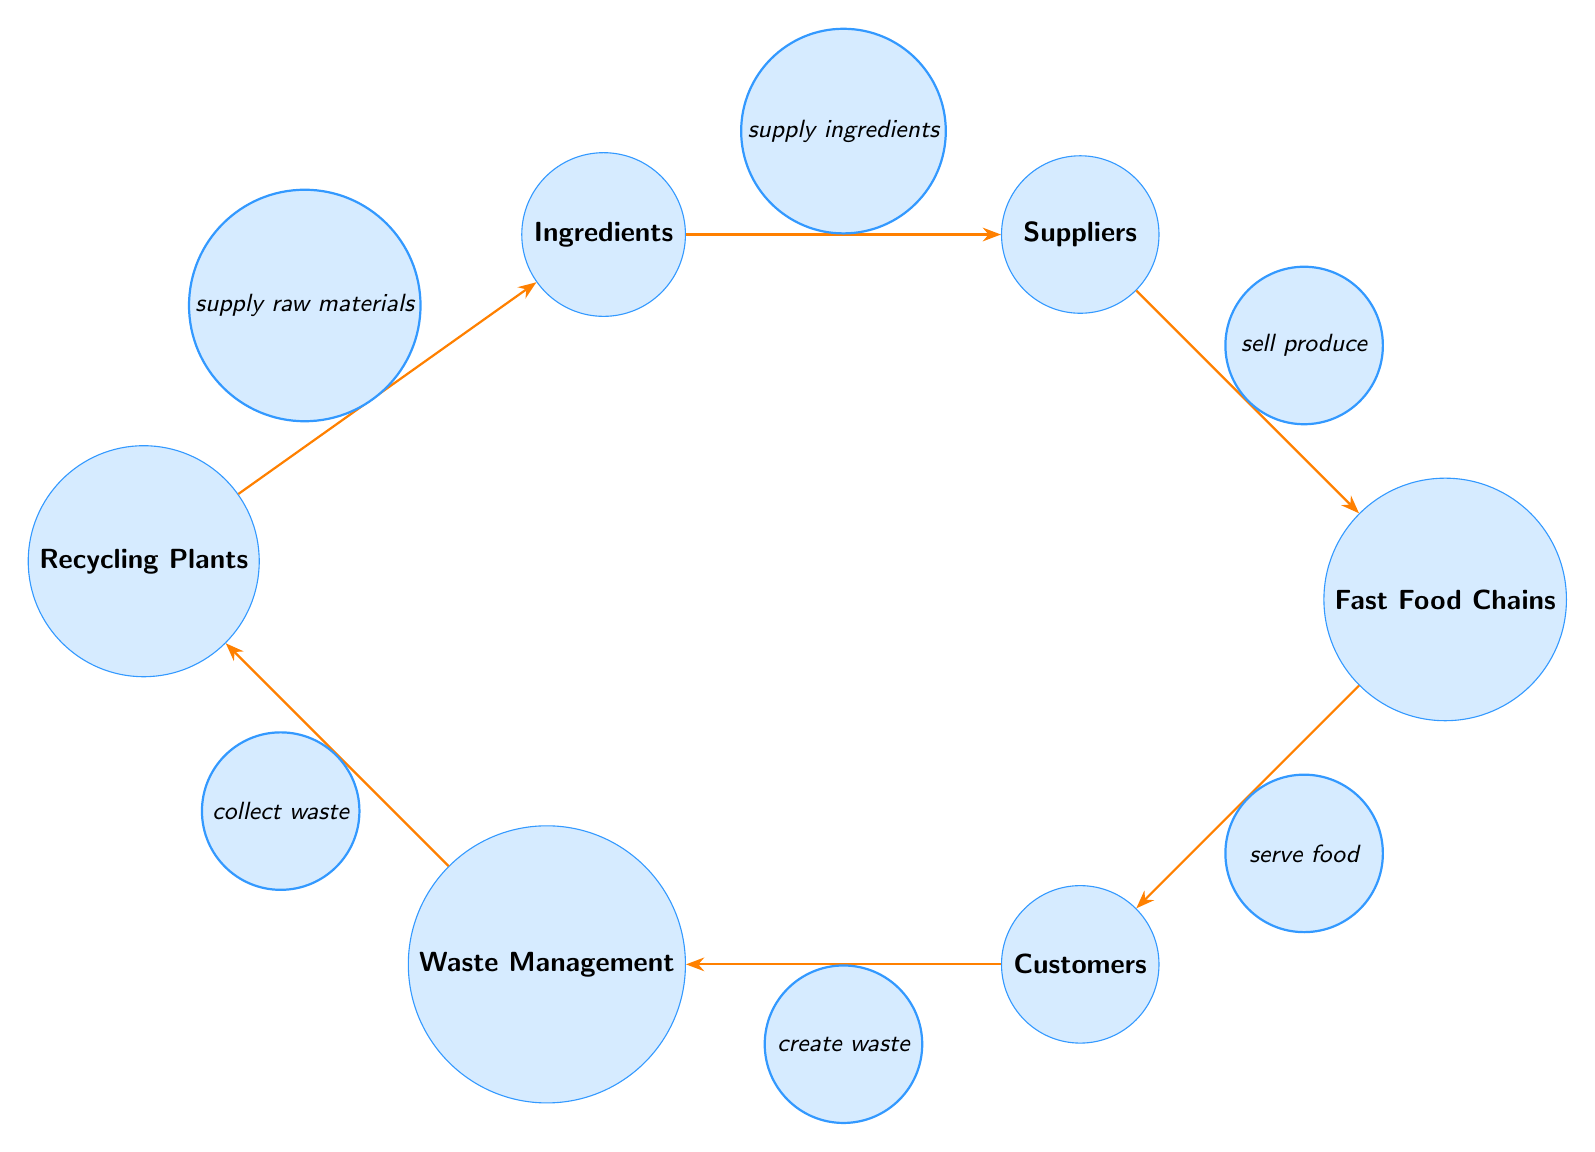What are the nodes present in the diagram? The nodes present in the diagram are: Ingredients, Suppliers, Fast Food Chains, Customers, Waste Management, Recycling Plants. Each node represents a key aspect of the food chain in fast food consumption.
Answer: Ingredients, Suppliers, Fast Food Chains, Customers, Waste Management, Recycling Plants How many nodes are there in total? By counting each distinct node displayed in the diagram, we find there are six nodes.
Answer: 6 What does the edge between Suppliers and Fast Food Chains represent? The edge labeled "sell produce" indicates the relationship where suppliers provide their goods to fast food chains. This connection shows the flow of products needed for fast food preparation.
Answer: sell produce What flow occurs after Customers in the diagram? Following the Customers node, the flow goes to Waste Management. This signifies that once customers consume the food, waste is created and managed accordingly.
Answer: Waste Management Which node is directly connected to Waste Management? The node that is directly connected to Waste Management is Customers, as they create waste after consuming food.
Answer: Customers Explain the connection from Recycling Plants to Ingredients. The connection from Recycling Plants to Ingredients is labeled "supply raw materials." This illustrates that materials recovered during recycling can be used to produce new ingredients for fast food, showing a circular economy in this food chain.
Answer: supply raw materials What role do Fast Food Chains play in the food chain process? Fast Food Chains serve food to Customers, acting as the intermediary that transforms ingredients into consumable meals. This is a critical step in the flow where food reaches the end consumer.
Answer: serve food If Waste Management is involved, what happens to the waste afterward? The waste collected from Customers goes to Recycling Plants, which is responsible for processing the waste. This process allows for the recovery of raw materials, establishing a loop back to the Ingredients node.
Answer: Recycling Plants Which nodes are involved in the supply chain of fast food from beginning to end? The nodes involved in the supply chain from start to finish include Ingredients, Suppliers, Fast Food Chains, Customers, Waste Management, and Recycling Plants. These all work sequentially to see how fast food reaches consumers and how waste is handled.
Answer: Ingredients, Suppliers, Fast Food Chains, Customers, Waste Management, Recycling Plants 